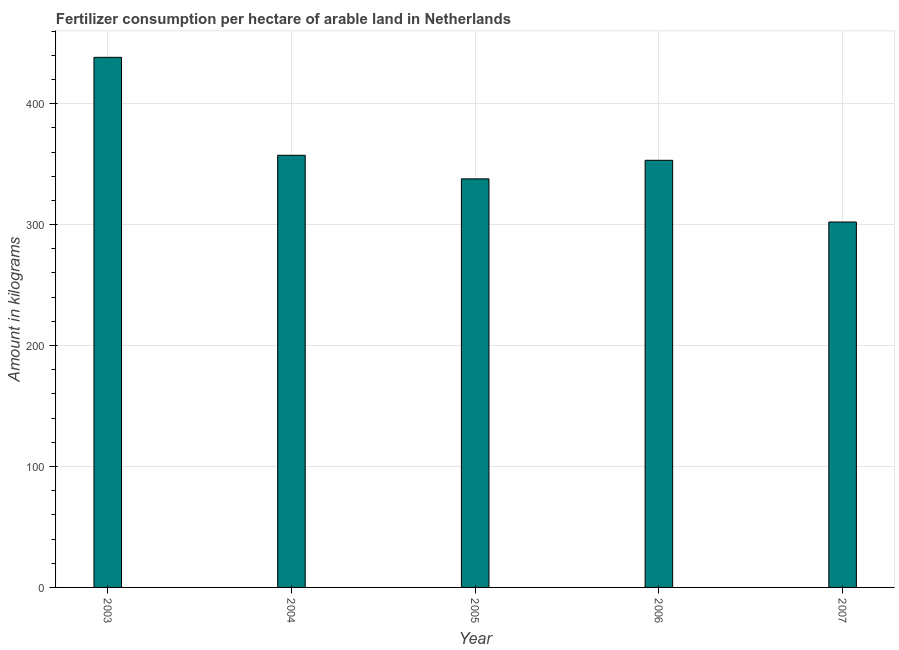What is the title of the graph?
Your answer should be compact. Fertilizer consumption per hectare of arable land in Netherlands . What is the label or title of the X-axis?
Your answer should be very brief. Year. What is the label or title of the Y-axis?
Provide a succinct answer. Amount in kilograms. What is the amount of fertilizer consumption in 2004?
Provide a succinct answer. 357.31. Across all years, what is the maximum amount of fertilizer consumption?
Provide a succinct answer. 438.29. Across all years, what is the minimum amount of fertilizer consumption?
Your response must be concise. 302.14. In which year was the amount of fertilizer consumption maximum?
Make the answer very short. 2003. What is the sum of the amount of fertilizer consumption?
Offer a very short reply. 1788.7. What is the difference between the amount of fertilizer consumption in 2004 and 2007?
Offer a very short reply. 55.17. What is the average amount of fertilizer consumption per year?
Your response must be concise. 357.74. What is the median amount of fertilizer consumption?
Keep it short and to the point. 353.15. Do a majority of the years between 2003 and 2006 (inclusive) have amount of fertilizer consumption greater than 40 kg?
Your answer should be very brief. Yes. Is the amount of fertilizer consumption in 2003 less than that in 2006?
Offer a very short reply. No. Is the difference between the amount of fertilizer consumption in 2003 and 2005 greater than the difference between any two years?
Keep it short and to the point. No. What is the difference between the highest and the second highest amount of fertilizer consumption?
Your answer should be compact. 80.98. What is the difference between the highest and the lowest amount of fertilizer consumption?
Give a very brief answer. 136.15. In how many years, is the amount of fertilizer consumption greater than the average amount of fertilizer consumption taken over all years?
Offer a terse response. 1. Are all the bars in the graph horizontal?
Your answer should be very brief. No. What is the difference between two consecutive major ticks on the Y-axis?
Offer a very short reply. 100. What is the Amount in kilograms in 2003?
Your answer should be very brief. 438.29. What is the Amount in kilograms in 2004?
Offer a terse response. 357.31. What is the Amount in kilograms in 2005?
Provide a succinct answer. 337.81. What is the Amount in kilograms of 2006?
Your answer should be very brief. 353.15. What is the Amount in kilograms of 2007?
Your answer should be compact. 302.14. What is the difference between the Amount in kilograms in 2003 and 2004?
Your response must be concise. 80.98. What is the difference between the Amount in kilograms in 2003 and 2005?
Provide a succinct answer. 100.48. What is the difference between the Amount in kilograms in 2003 and 2006?
Give a very brief answer. 85.15. What is the difference between the Amount in kilograms in 2003 and 2007?
Keep it short and to the point. 136.15. What is the difference between the Amount in kilograms in 2004 and 2005?
Your response must be concise. 19.51. What is the difference between the Amount in kilograms in 2004 and 2006?
Give a very brief answer. 4.17. What is the difference between the Amount in kilograms in 2004 and 2007?
Your answer should be compact. 55.17. What is the difference between the Amount in kilograms in 2005 and 2006?
Your answer should be very brief. -15.34. What is the difference between the Amount in kilograms in 2005 and 2007?
Your answer should be compact. 35.67. What is the difference between the Amount in kilograms in 2006 and 2007?
Your response must be concise. 51.01. What is the ratio of the Amount in kilograms in 2003 to that in 2004?
Offer a terse response. 1.23. What is the ratio of the Amount in kilograms in 2003 to that in 2005?
Make the answer very short. 1.3. What is the ratio of the Amount in kilograms in 2003 to that in 2006?
Offer a very short reply. 1.24. What is the ratio of the Amount in kilograms in 2003 to that in 2007?
Offer a terse response. 1.45. What is the ratio of the Amount in kilograms in 2004 to that in 2005?
Your answer should be compact. 1.06. What is the ratio of the Amount in kilograms in 2004 to that in 2006?
Ensure brevity in your answer.  1.01. What is the ratio of the Amount in kilograms in 2004 to that in 2007?
Provide a short and direct response. 1.18. What is the ratio of the Amount in kilograms in 2005 to that in 2006?
Your answer should be compact. 0.96. What is the ratio of the Amount in kilograms in 2005 to that in 2007?
Keep it short and to the point. 1.12. What is the ratio of the Amount in kilograms in 2006 to that in 2007?
Your answer should be very brief. 1.17. 